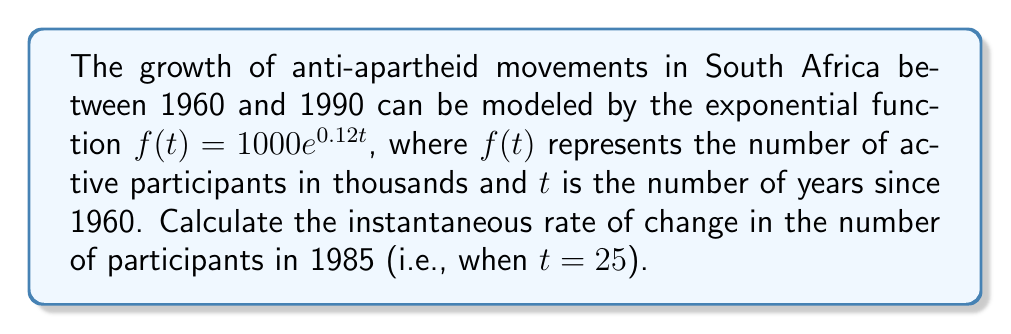Help me with this question. To find the instantaneous rate of change, we need to calculate the derivative of the function $f(t)$ and evaluate it at $t = 25$.

1. The given function is $f(t) = 1000e^{0.12t}$

2. The derivative of $e^x$ is $e^x$, and using the chain rule, we get:
   $$f'(t) = 1000 \cdot 0.12 \cdot e^{0.12t} = 120e^{0.12t}$$

3. Now, we evaluate $f'(t)$ at $t = 25$:
   $$f'(25) = 120e^{0.12 \cdot 25} = 120e^3$$

4. Calculate $e^3$:
   $$e^3 \approx 20.0855$$

5. Multiply by 120:
   $$120 \cdot 20.0855 \approx 2410.26$$

This result represents the instantaneous rate of change in thousands of participants per year. To convert it to participants per year, we multiply by 1000:

$$2410.26 \cdot 1000 \approx 2,410,260$$

Therefore, in 1985, the anti-apartheid movement was growing at a rate of approximately 2,410,260 participants per year.
Answer: The instantaneous rate of change in the number of anti-apartheid movement participants in 1985 was approximately 2,410,260 people per year. 